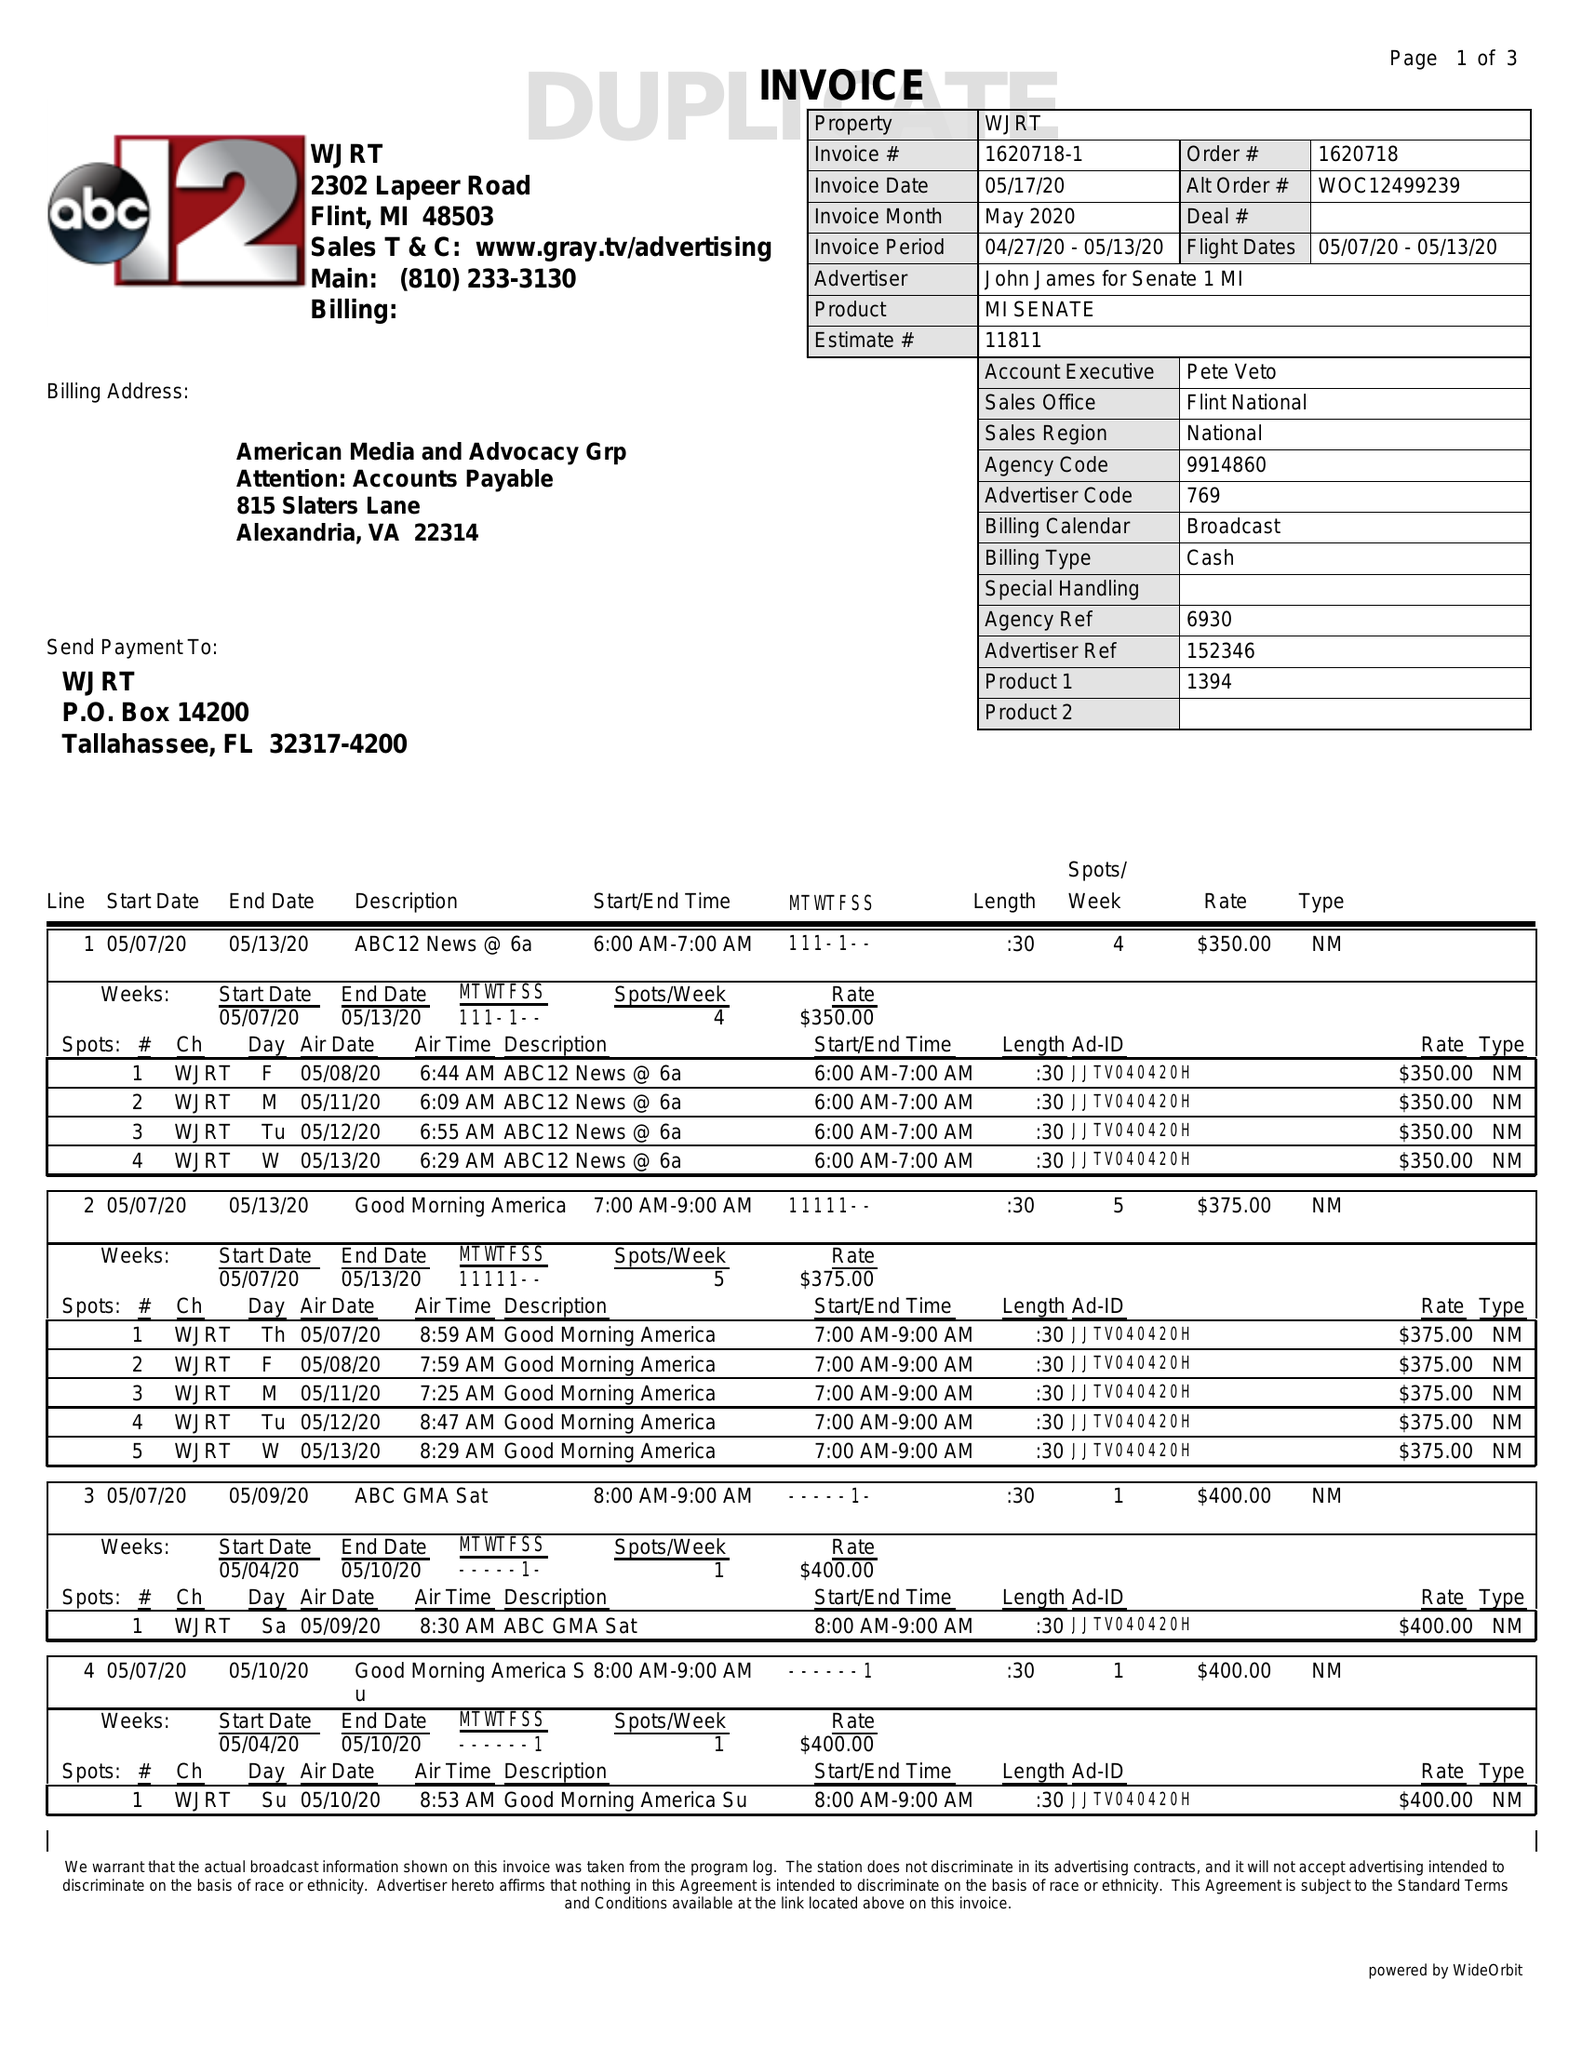What is the value for the advertiser?
Answer the question using a single word or phrase. JOHN JAMES FOR SENATE 1 MI 